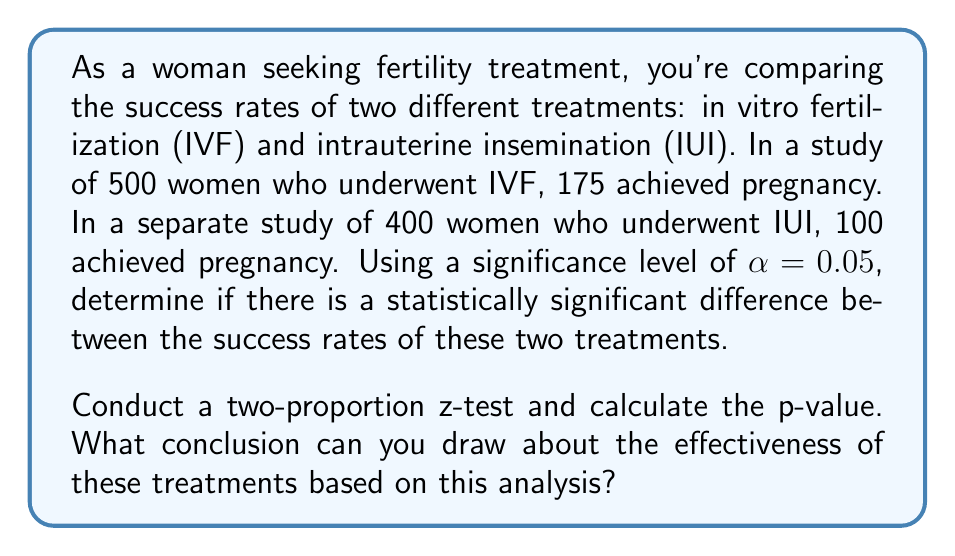Give your solution to this math problem. To solve this problem, we'll follow these steps:

1) First, let's define our hypotheses:
   $H_0: p_{IVF} = p_{IUI}$ (null hypothesis)
   $H_a: p_{IVF} \neq p_{IUI}$ (alternative hypothesis)

2) Calculate the sample proportions:
   $\hat{p}_{IVF} = \frac{175}{500} = 0.35$
   $\hat{p}_{IUI} = \frac{100}{400} = 0.25$

3) Calculate the pooled sample proportion:
   $$\hat{p} = \frac{X_1 + X_2}{n_1 + n_2} = \frac{175 + 100}{500 + 400} = \frac{275}{900} ≈ 0.3056$$

4) Calculate the standard error:
   $$SE = \sqrt{\hat{p}(1-\hat{p})(\frac{1}{n_1} + \frac{1}{n_2})}$$
   $$SE = \sqrt{0.3056(1-0.3056)(\frac{1}{500} + \frac{1}{400})} ≈ 0.0316$$

5) Calculate the z-statistic:
   $$z = \frac{\hat{p}_{IVF} - \hat{p}_{IUI}}{SE} = \frac{0.35 - 0.25}{0.0316} ≈ 3.1646$$

6) Calculate the p-value:
   For a two-tailed test, p-value = 2 * P(Z > |z|)
   Using a standard normal distribution table or calculator:
   p-value ≈ 2 * 0.00078 = 0.00156

7) Compare the p-value to the significance level:
   0.00156 < 0.05

Since the p-value (0.00156) is less than the significance level (0.05), we reject the null hypothesis.
Answer: We can conclude that there is a statistically significant difference between the success rates of IVF and IUI treatments (p = 0.00156 < 0.05). The data suggests that IVF has a higher success rate than IUI. However, it's important to note that other factors such as age, health conditions, and individual circumstances should also be considered when choosing a fertility treatment. 